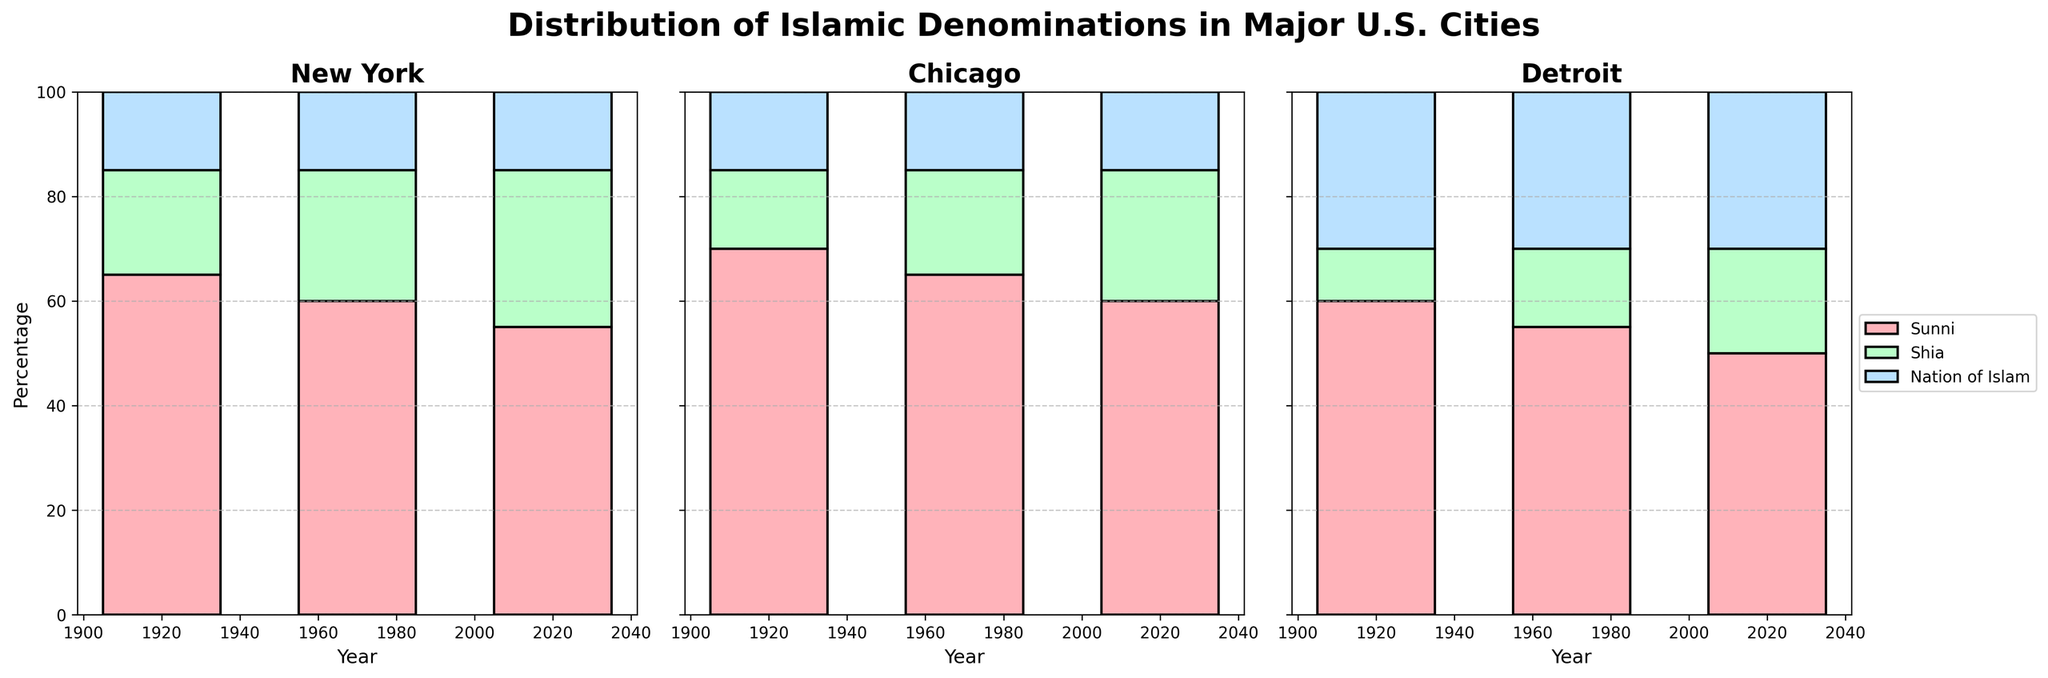What is the title of the figure? The title is displayed at the top center of the figure in larger, bold font.
Answer: Distribution of Islamic Denominations in Major U.S. Cities Which city has the highest percentage of Shia Muslims in 2020? Looking at the bars for Shia Muslims in 2020 across all cities, the one with the highest bar is Detroit.
Answer: Detroit What is the color associated with Nation of Islam in the plot? Nation of Islam segments are consistently colored light blue across the entire figure.
Answer: Light blue How has the percentage of Sunni Muslims changed in Chicago from 1920 to 2020? For Chicago, the height of the Sunni Muslim bars is 70% in 1920, 65% in 1970, and 60% in 2020. So, it decreased by 10%.
Answer: Decreased by 10% Which city observed the least change in the percentage of Nation of Islam followers from 1920 to 2020? By checking the Nation of Islam bars for each city from 1920 to 2020, New York maintains a constant 15%, showing no change.
Answer: New York Compare the percentage of Shia Muslims between New York and Chicago in 1970. Which city has a higher percentage? In 1970, New York has 25% Shia Muslims while Chicago has 20%. So, New York has a higher percentage.
Answer: New York What percentage of Muslims in Detroit were Sunni in 1970? By looking at the bar for Sunni Muslims in Detroit for the year 1970, we can see it reads 55%.
Answer: 55% What can be observed about the trend of Nation of Islam followers in the three cities over the century? Nation of Islam shows no change across all three cities for the entire century, remaining at 15% in New York and Chicago, and 30% in Detroit.
Answer: Steady Which city has the largest percentage of Sunni Muslims in 1920, and what is that percentage? Checking the Sunni Muslim bars for 1920 in all cities, Chicago has the largest percentage with 70%.
Answer: Chicago, 70% What is the sum of the percentages of Shia and Nation of Islam in New York in 2020? In New York, the percentage for Shia in 2020 is 30%, and for Nation of Islam is 15%. The sum is 30 + 15 = 45%.
Answer: 45% 